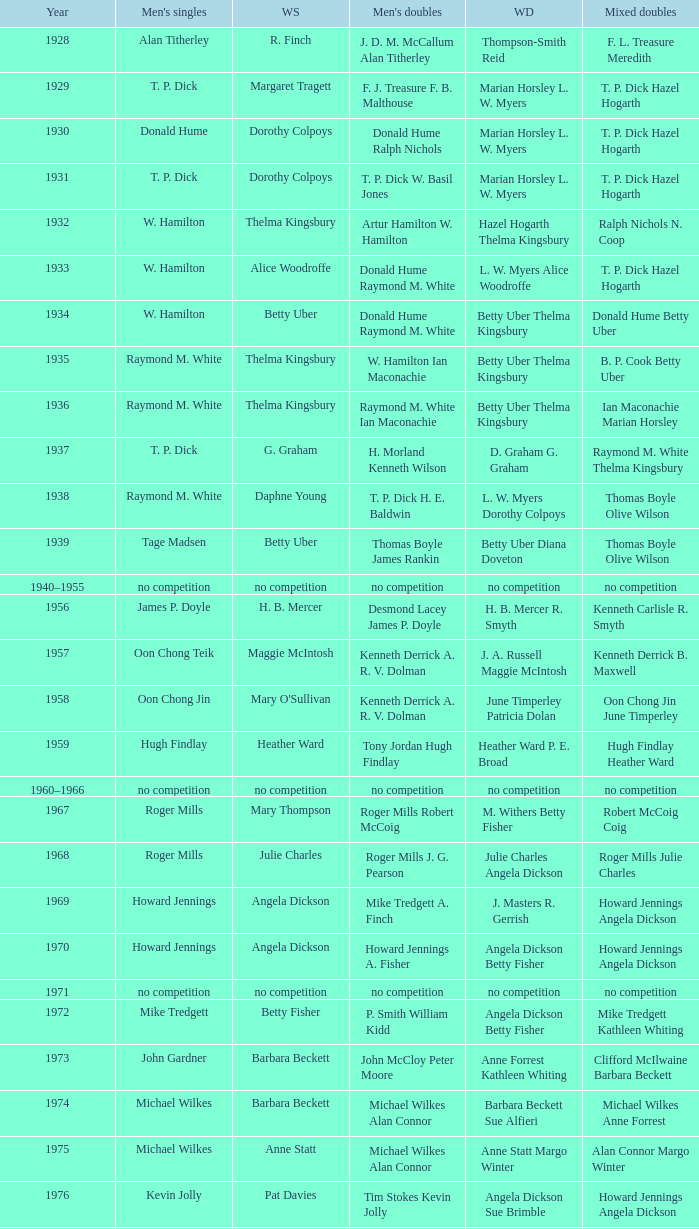Who won the Women's doubles in the year that David Eddy Eddy Sutton won the Men's doubles, and that David Eddy won the Men's singles? Anne Statt Jane Webster. 